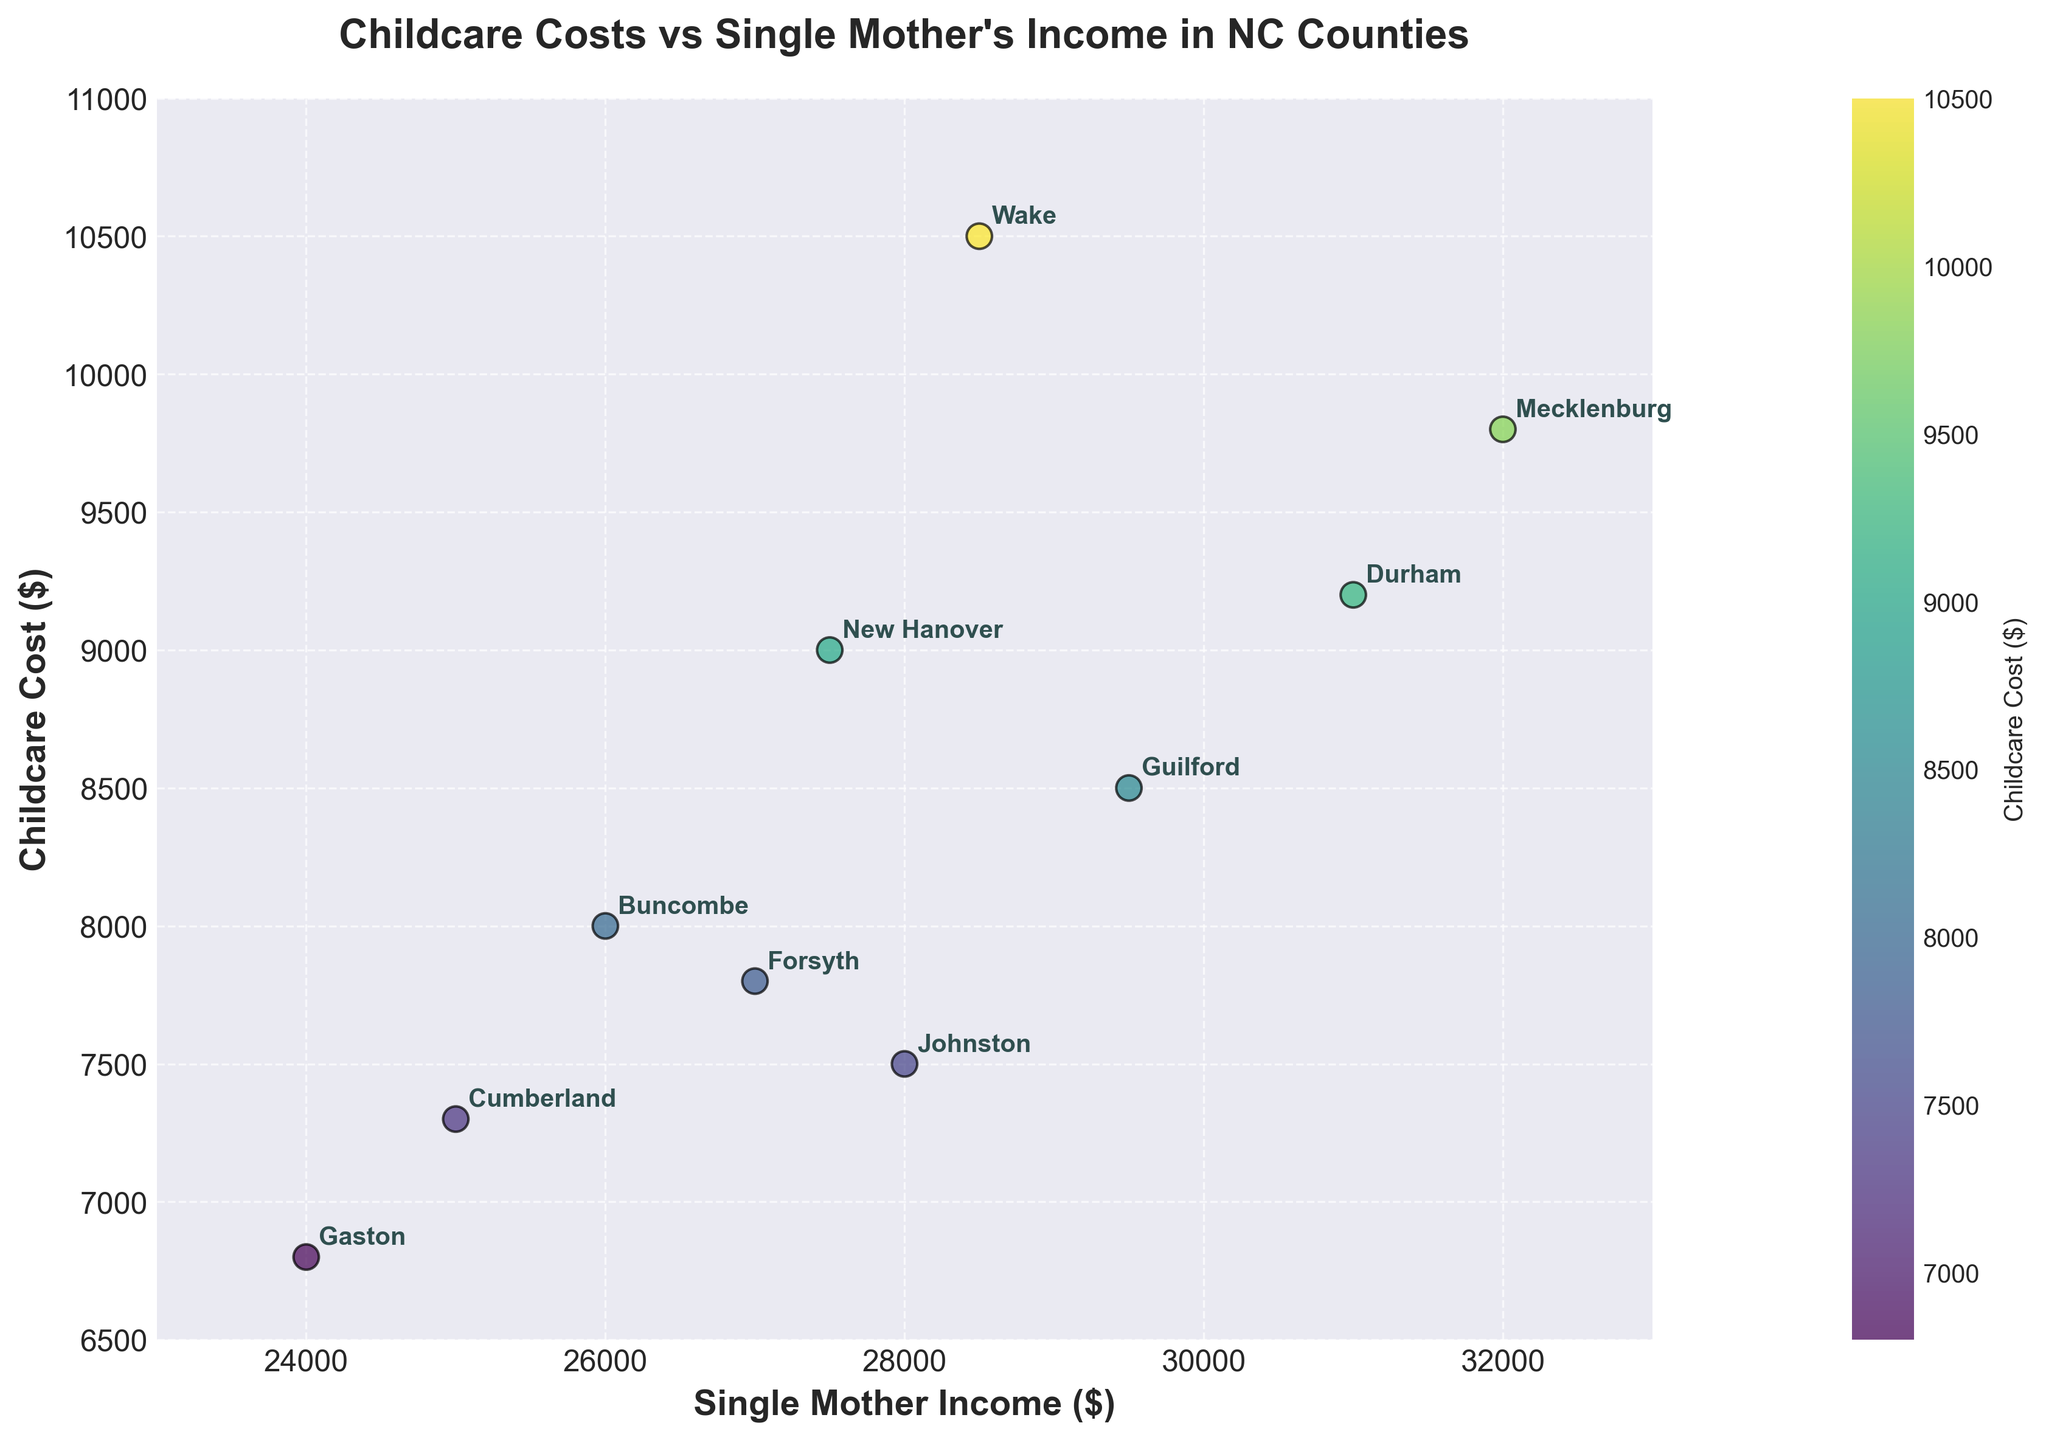What is the title of the plot? The title of the plot is displayed prominently at the top of the figure. By reading it, we can see the main theme of the scatter plot.
Answer: Childcare Costs vs Single Mother's Income in NC Counties How many counties are represented in the plot? By counting the number of data points on the scatter plot, each labeled with a county name, we can determine the number of counties.
Answer: 10 What's the highest childcare cost shown in the plot, and in which county? By locating the highest y-value on the scatter plot, we can identify the corresponding childcare cost and the county it's associated with.
Answer: 10500, Wake Which county has the lowest single mother income? By finding the data point with the smallest x-value, we can identify the corresponding single mother income and the county it's associated with.
Answer: Gaston What is the range of single mother income values in the counties? To calculate the range, find the difference between the highest and lowest single mother income values on the x-axis.
Answer: 32000 - 24000 = 8000 Which counties have a childcare cost higher than $9000? By examining the y-values above $9000 and noting the corresponding county names, we can identify the counties.
Answer: Wake, Mecklenburg, New Hanover Do childcare costs increase with single mother income? By observing the overall trend of the scatter plot, we can assess whether the data points show an upward slope, indicating a potential positive relationship.
Answer: No clear trend What is the average childcare cost across all counties? Sum all the childcare costs and divide by the number of counties (10) to find the average cost.
Answer: (10500 + 9800 + 8500 + 9200 + 7800 + 7300 + 8000 + 9000 + 6800 + 7500) / 10 = 8410 Is there any county where the childcare cost is almost equal to half of the single mother income? For each data point, compare the childcare cost to half of the single mother income and find any matches.
Answer: Yes, Johnston (7500 ≈ 28000/2) Which counties have a childcare cost below the average childcare cost? Calculate the average childcare cost as before, then identify counties with childcare costs below this value.
Answer: Forsyth, Cumberland, Buncombe, Gaston, Johnston 